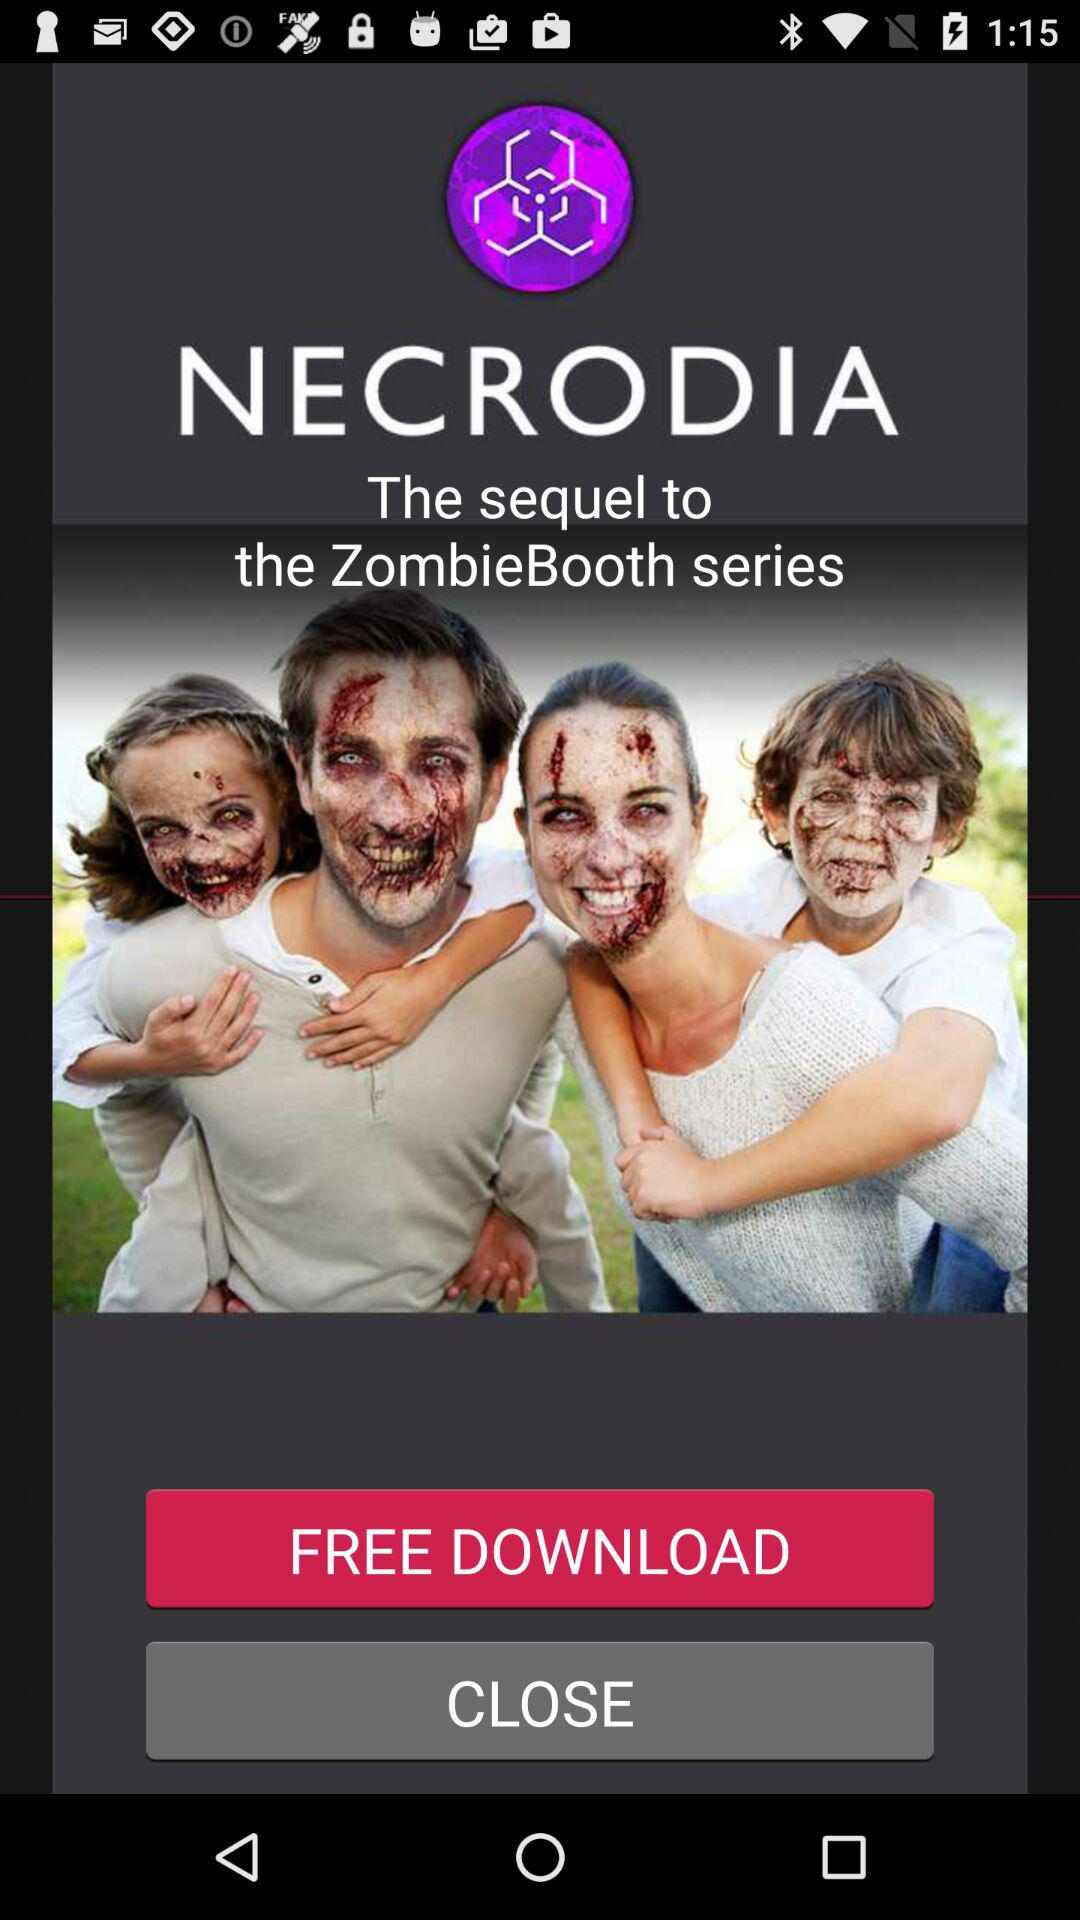What is the name of the application? The name of the application is "NECRODIA". 